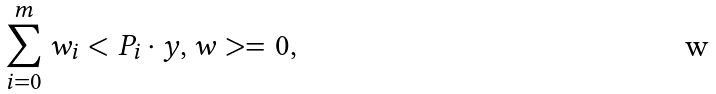Convert formula to latex. <formula><loc_0><loc_0><loc_500><loc_500>\sum _ { i = 0 } ^ { m } w _ { i } < P _ { i } \cdot y , w > = 0 ,</formula> 